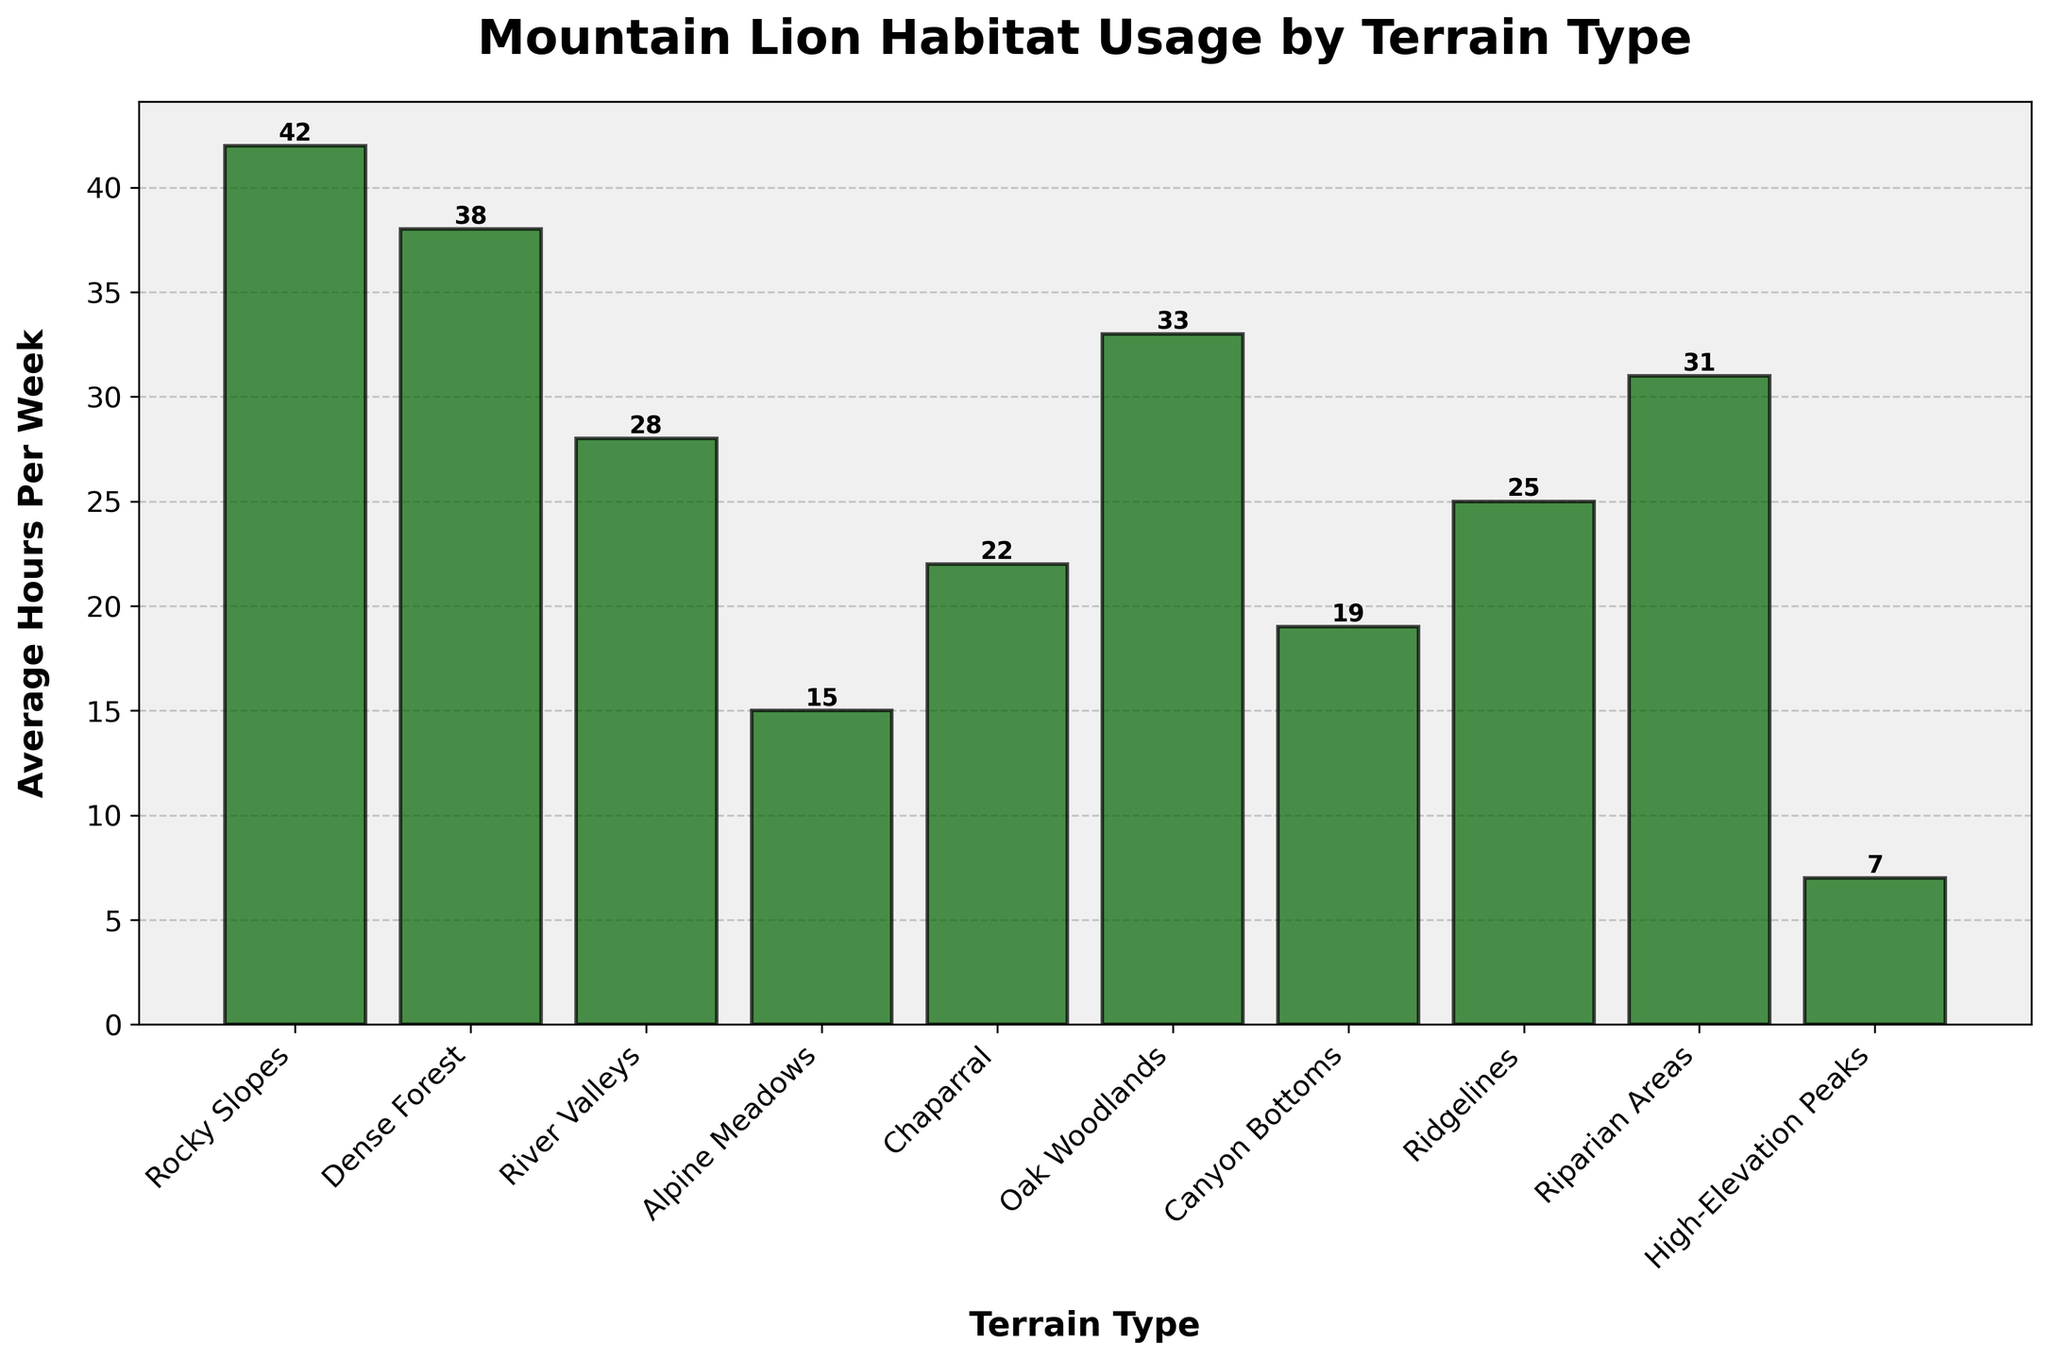What's the terrain type that mountain lions use the most? The terrain type with the tallest bar represents the most used terrain. The tallest bar corresponds to Rocky Slopes, which has the highest average hours per week (42)
Answer: Rocky Slopes Which terrain type has the lowest average hours per week usage by mountain lions? The terrain type with the shortest bar represents the least used terrain. The shortest bar corresponds to High-Elevation Peaks, with 7 average hours per week
Answer: High-Elevation Peaks How many more hours do mountain lions spend in Rocky Slopes compared to Alpine Meadows on average per week? Subtract the average hours spent in Alpine Meadows (15) from the average hours spent in Rocky Slopes (42): 42 - 15 = 27
Answer: 27 Arrange the following terrain types in decreasing order of usage: Riparian Areas, Oak Woodlands, and Canyon Bottoms. Compare the heights of the bars for Riparian Areas (31), Oak Woodlands (33), and Canyon Bottoms (19). Order them from greatest to least: Oak Woodlands (33), Riparian Areas (31), Canyon Bottoms (19)
Answer: Oak Woodlands, Riparian Areas, Canyon Bottoms What is the combined total average hours per week spent by mountain lions in Dense Forest and River Valleys? Add the average hours spent in Dense Forest (38) and River Valleys (28): 38 + 28 = 66
Answer: 66 Do mountain lions spend more time in Chaparral or Canyon Bottoms? Compare the heights of the bars for Chaparral (22) and Canyon Bottoms (19). The bar for Chaparral is taller, indicating it has a higher average hour usage
Answer: Chaparral How much difference is there in the average hours per week between the terrain types with the highest and lowest usage? Subtract the average hours of High-Elevation Peaks (7, the lowest usage) from Rocky Slopes (42, the highest usage): 42 - 7 = 35
Answer: 35 Among Riparian Areas, Ridgelines, and Canyon Bottoms, which terrain type has the median usage? Identify and list the average hours: Riparian Areas (31), Ridgelines (25), and Canyon Bottoms (19). The median value is the middle one when ordered: Canyon Bottoms (19), Ridgelines (25), Riparian Areas (31). The median is 25
Answer: Ridgelines Which terrain type has a bar visually approximately halfway in height between Alpine Meadows and Oak Woodlands? First find the average hours for Alpine Meadows (15) and Oak Woodlands (33). Their average is (15+33)/2 = 24. The bar that is close to 24 hours is Ridgelines (25)
Answer: Ridgelines 